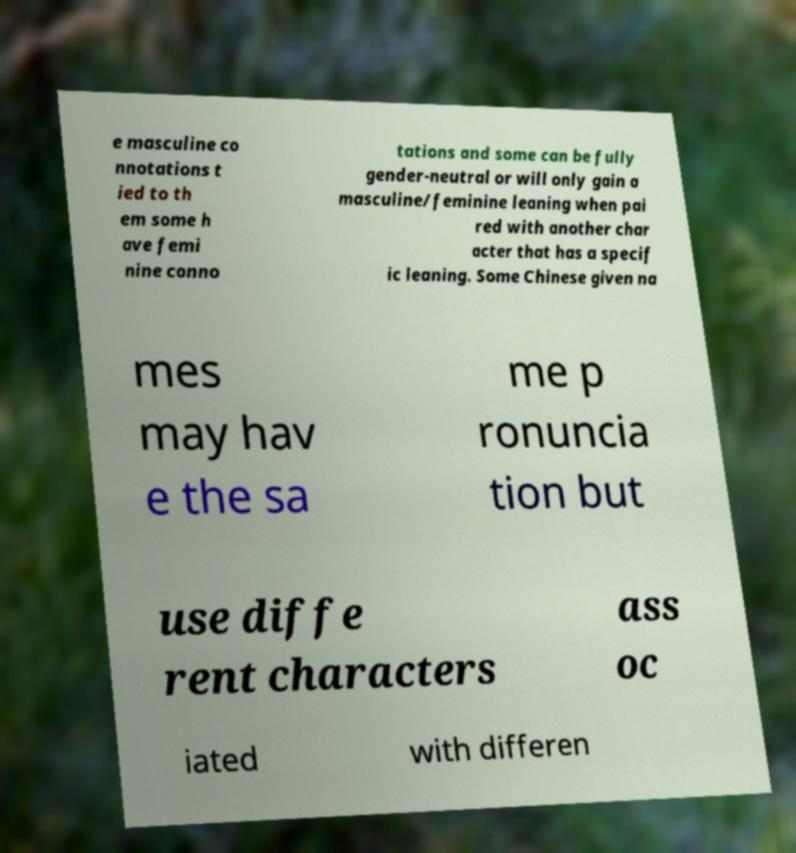There's text embedded in this image that I need extracted. Can you transcribe it verbatim? e masculine co nnotations t ied to th em some h ave femi nine conno tations and some can be fully gender-neutral or will only gain a masculine/feminine leaning when pai red with another char acter that has a specif ic leaning. Some Chinese given na mes may hav e the sa me p ronuncia tion but use diffe rent characters ass oc iated with differen 